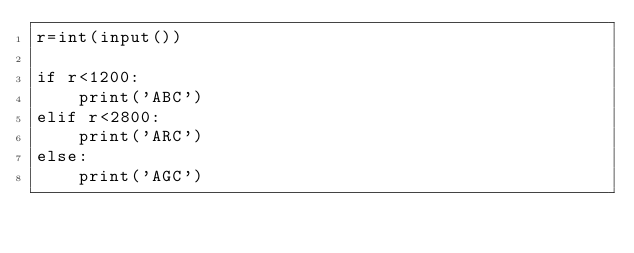Convert code to text. <code><loc_0><loc_0><loc_500><loc_500><_Python_>r=int(input())

if r<1200:
    print('ABC')
elif r<2800:
    print('ARC')
else:
    print('AGC')
</code> 